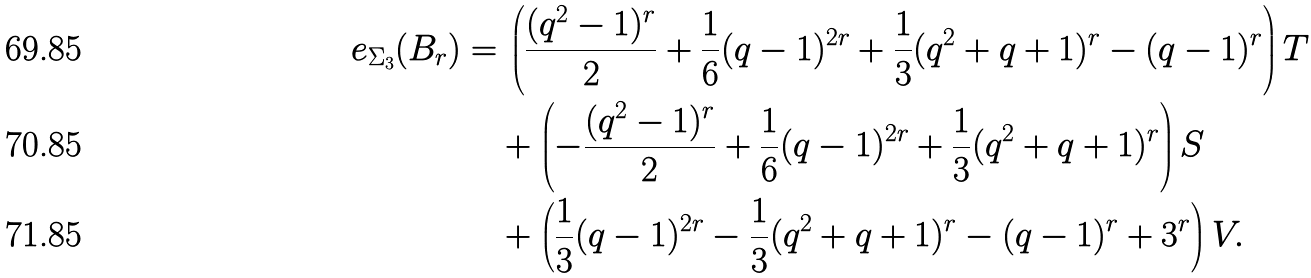<formula> <loc_0><loc_0><loc_500><loc_500>e _ { \Sigma _ { 3 } } ( B _ { r } ) = & \, \left ( \frac { ( q ^ { 2 } - 1 ) ^ { r } } 2 + \frac { 1 } { 6 } ( q - 1 ) ^ { 2 r } + \frac { 1 } { 3 } ( q ^ { 2 } + q + 1 ) ^ { r } - ( q - 1 ) ^ { r } \right ) T \\ & + \left ( - \frac { ( q ^ { 2 } - 1 ) ^ { r } } 2 + \frac { 1 } { 6 } ( q - 1 ) ^ { 2 r } + \frac { 1 } { 3 } ( q ^ { 2 } + q + 1 ) ^ { r } \right ) S \\ & + \left ( \frac { 1 } { 3 } ( q - 1 ) ^ { 2 r } - \frac { 1 } { 3 } ( q ^ { 2 } + q + 1 ) ^ { r } - ( q - 1 ) ^ { r } + 3 ^ { r } \right ) V .</formula> 